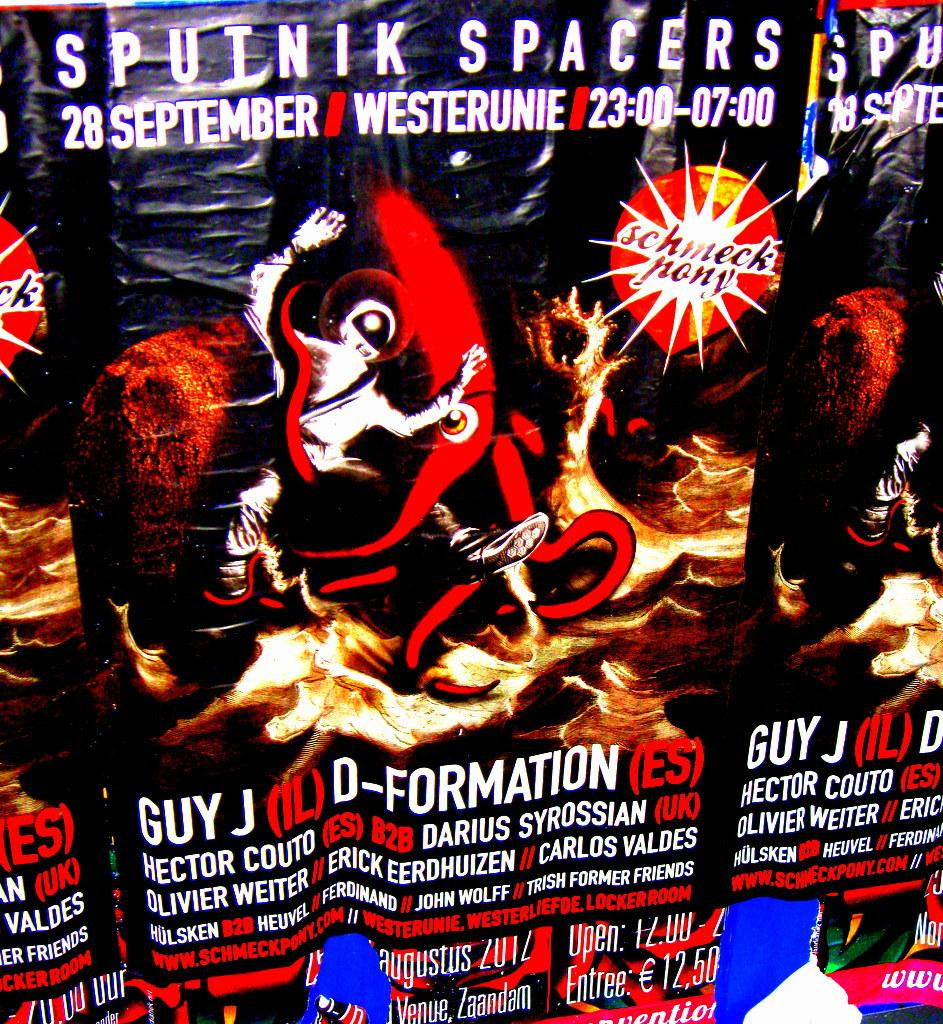Provide a one-sentence caption for the provided image. A poster for a rave on the 28th Spetember in Germany tells us Guy J, D-formation and many others will be taking part. 